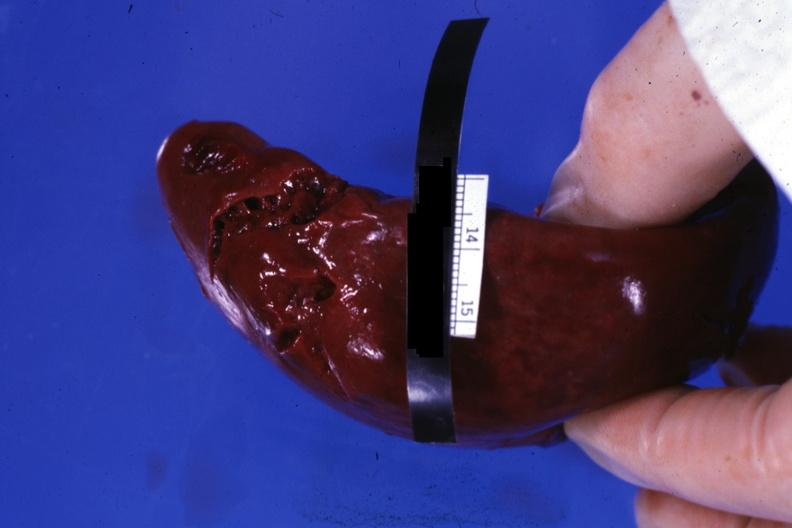what is present?
Answer the question using a single word or phrase. Hematologic 